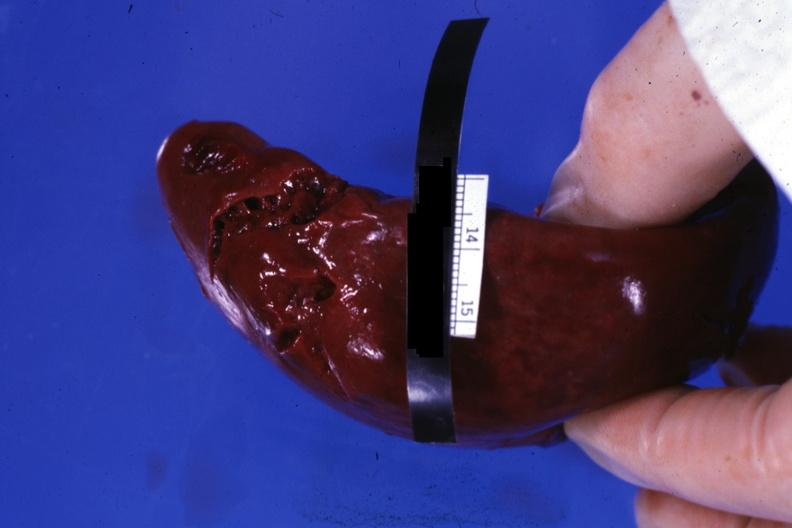what is present?
Answer the question using a single word or phrase. Hematologic 